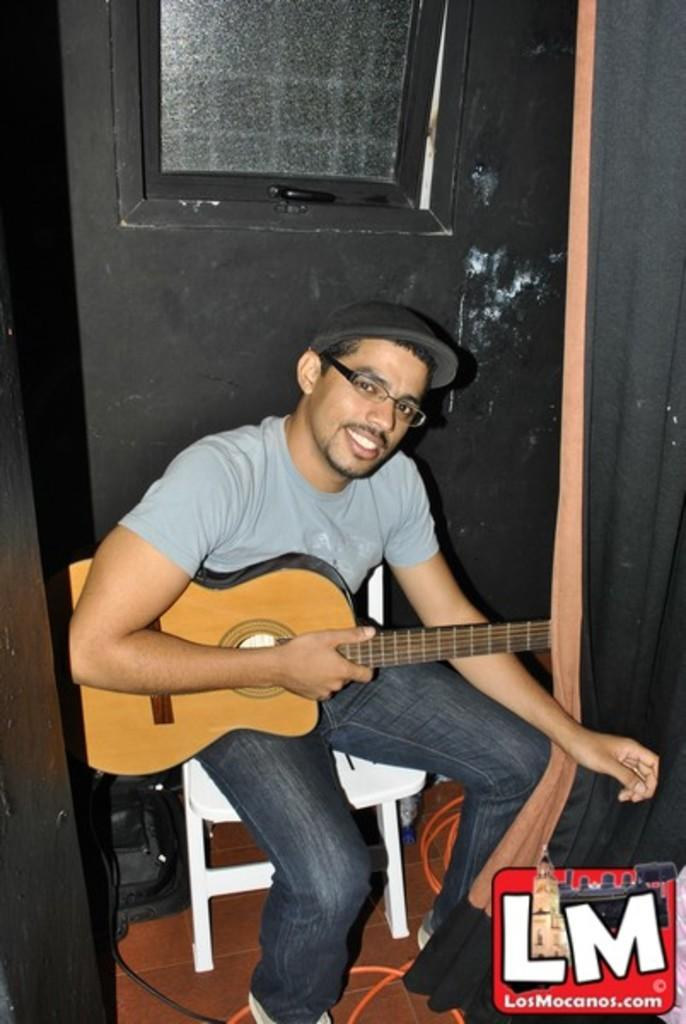What is the main subject of the image? There is a person in the image. What can be observed about the person's attire? The person is wearing a black hat. What is the person doing in the image? The person is sitting on a chair. What object is the person holding in their hands? The person is holding a guitar in their hands. What type of plastic material is being distributed by the person in the image? There is no plastic material being distributed by the person in the image; they are holding a guitar. How is the butter being used by the person in the image? There is no butter present in the image; the person is holding a guitar. 